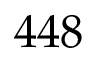Convert formula to latex. <formula><loc_0><loc_0><loc_500><loc_500>4 4 8</formula> 